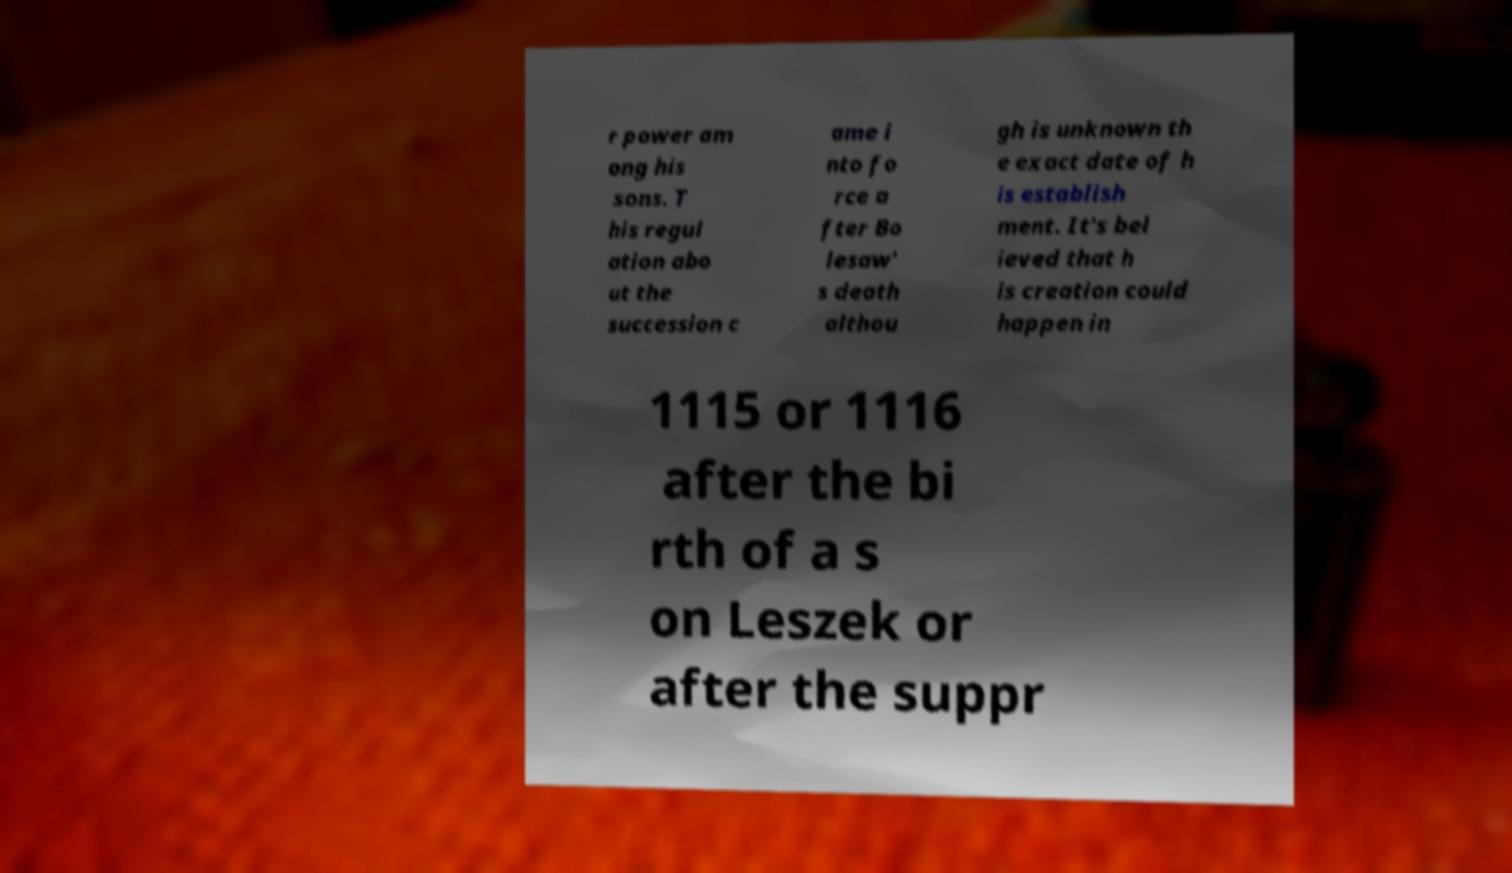Could you extract and type out the text from this image? r power am ong his sons. T his regul ation abo ut the succession c ame i nto fo rce a fter Bo lesaw' s death althou gh is unknown th e exact date of h is establish ment. It's bel ieved that h is creation could happen in 1115 or 1116 after the bi rth of a s on Leszek or after the suppr 